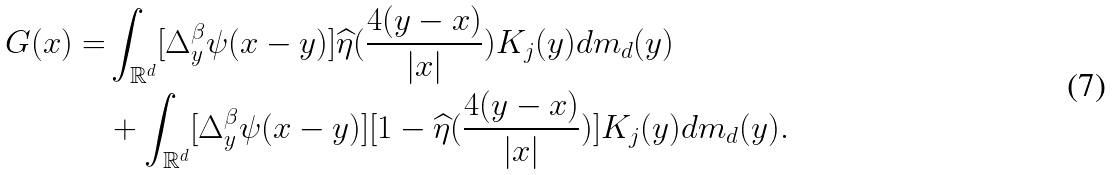<formula> <loc_0><loc_0><loc_500><loc_500>G ( x ) = & \int _ { \mathbb { R } ^ { d } } [ \Delta ^ { \beta } _ { y } \psi ( x - y ) ] \widehat { \eta } ( \frac { 4 ( y - x ) } { | x | } ) K _ { j } ( y ) d m _ { d } ( y ) \\ & + \int _ { \mathbb { R } ^ { d } } [ \Delta ^ { \beta } _ { y } \psi ( x - y ) ] [ 1 - \widehat { \eta } ( \frac { 4 ( y - x ) } { | x | } ) ] K _ { j } ( y ) d m _ { d } ( y ) .</formula> 